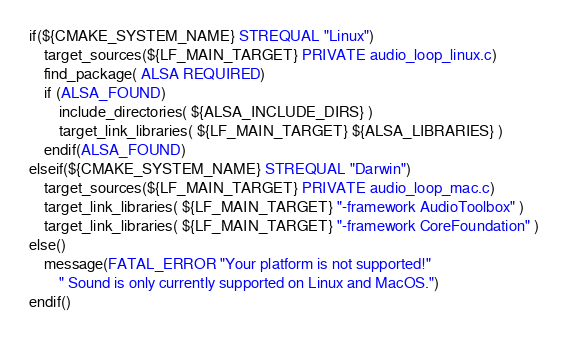<code> <loc_0><loc_0><loc_500><loc_500><_CMake_>if(${CMAKE_SYSTEM_NAME} STREQUAL "Linux")
    target_sources(${LF_MAIN_TARGET} PRIVATE audio_loop_linux.c)
    find_package( ALSA REQUIRED)
    if (ALSA_FOUND)
        include_directories( ${ALSA_INCLUDE_DIRS} )
        target_link_libraries( ${LF_MAIN_TARGET} ${ALSA_LIBRARIES} )
    endif(ALSA_FOUND)
elseif(${CMAKE_SYSTEM_NAME} STREQUAL "Darwin")
    target_sources(${LF_MAIN_TARGET} PRIVATE audio_loop_mac.c)
    target_link_libraries( ${LF_MAIN_TARGET} "-framework AudioToolbox" )
    target_link_libraries( ${LF_MAIN_TARGET} "-framework CoreFoundation" )
else()
    message(FATAL_ERROR "Your platform is not supported!"
        " Sound is only currently supported on Linux and MacOS.")
endif()</code> 